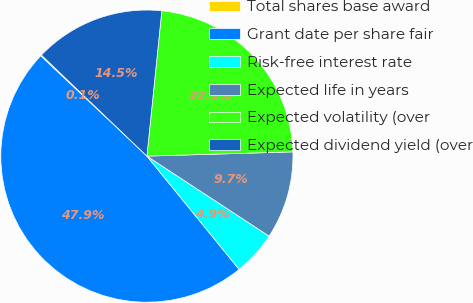<chart> <loc_0><loc_0><loc_500><loc_500><pie_chart><fcel>Total shares base award<fcel>Grant date per share fair<fcel>Risk-free interest rate<fcel>Expected life in years<fcel>Expected volatility (over<fcel>Expected dividend yield (over<nl><fcel>0.12%<fcel>47.91%<fcel>4.9%<fcel>9.69%<fcel>22.91%<fcel>14.47%<nl></chart> 